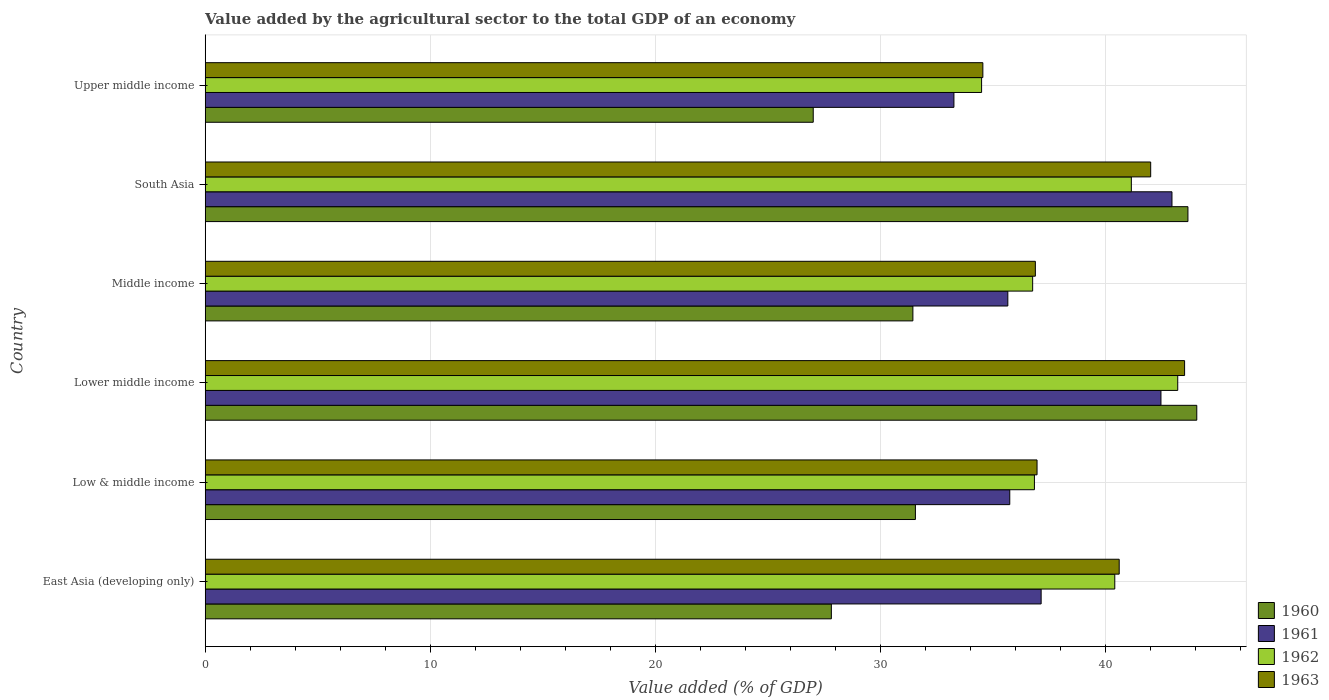How many groups of bars are there?
Your answer should be very brief. 6. Are the number of bars per tick equal to the number of legend labels?
Make the answer very short. Yes. How many bars are there on the 6th tick from the top?
Provide a short and direct response. 4. How many bars are there on the 4th tick from the bottom?
Make the answer very short. 4. In how many cases, is the number of bars for a given country not equal to the number of legend labels?
Give a very brief answer. 0. What is the value added by the agricultural sector to the total GDP in 1962 in South Asia?
Make the answer very short. 41.16. Across all countries, what is the maximum value added by the agricultural sector to the total GDP in 1962?
Your answer should be very brief. 43.22. Across all countries, what is the minimum value added by the agricultural sector to the total GDP in 1962?
Provide a succinct answer. 34.5. In which country was the value added by the agricultural sector to the total GDP in 1960 maximum?
Offer a terse response. Lower middle income. In which country was the value added by the agricultural sector to the total GDP in 1962 minimum?
Your answer should be compact. Upper middle income. What is the total value added by the agricultural sector to the total GDP in 1962 in the graph?
Your answer should be very brief. 232.94. What is the difference between the value added by the agricultural sector to the total GDP in 1960 in East Asia (developing only) and that in Upper middle income?
Provide a succinct answer. 0.81. What is the difference between the value added by the agricultural sector to the total GDP in 1960 in South Asia and the value added by the agricultural sector to the total GDP in 1963 in Middle income?
Your answer should be compact. 6.78. What is the average value added by the agricultural sector to the total GDP in 1963 per country?
Offer a terse response. 39.1. What is the difference between the value added by the agricultural sector to the total GDP in 1961 and value added by the agricultural sector to the total GDP in 1962 in East Asia (developing only)?
Keep it short and to the point. -3.27. In how many countries, is the value added by the agricultural sector to the total GDP in 1960 greater than 4 %?
Your response must be concise. 6. What is the ratio of the value added by the agricultural sector to the total GDP in 1963 in East Asia (developing only) to that in Middle income?
Make the answer very short. 1.1. Is the value added by the agricultural sector to the total GDP in 1962 in Lower middle income less than that in South Asia?
Keep it short and to the point. No. Is the difference between the value added by the agricultural sector to the total GDP in 1961 in Low & middle income and Lower middle income greater than the difference between the value added by the agricultural sector to the total GDP in 1962 in Low & middle income and Lower middle income?
Your answer should be compact. No. What is the difference between the highest and the second highest value added by the agricultural sector to the total GDP in 1962?
Provide a succinct answer. 2.06. What is the difference between the highest and the lowest value added by the agricultural sector to the total GDP in 1961?
Give a very brief answer. 9.69. In how many countries, is the value added by the agricultural sector to the total GDP in 1963 greater than the average value added by the agricultural sector to the total GDP in 1963 taken over all countries?
Give a very brief answer. 3. Is it the case that in every country, the sum of the value added by the agricultural sector to the total GDP in 1962 and value added by the agricultural sector to the total GDP in 1961 is greater than the sum of value added by the agricultural sector to the total GDP in 1963 and value added by the agricultural sector to the total GDP in 1960?
Offer a very short reply. No. What does the 4th bar from the top in Middle income represents?
Give a very brief answer. 1960. What does the 2nd bar from the bottom in South Asia represents?
Offer a very short reply. 1961. Is it the case that in every country, the sum of the value added by the agricultural sector to the total GDP in 1961 and value added by the agricultural sector to the total GDP in 1963 is greater than the value added by the agricultural sector to the total GDP in 1960?
Your answer should be compact. Yes. Are all the bars in the graph horizontal?
Keep it short and to the point. Yes. How many countries are there in the graph?
Give a very brief answer. 6. Are the values on the major ticks of X-axis written in scientific E-notation?
Provide a short and direct response. No. How many legend labels are there?
Offer a terse response. 4. How are the legend labels stacked?
Offer a terse response. Vertical. What is the title of the graph?
Provide a short and direct response. Value added by the agricultural sector to the total GDP of an economy. Does "1983" appear as one of the legend labels in the graph?
Keep it short and to the point. No. What is the label or title of the X-axis?
Your answer should be compact. Value added (% of GDP). What is the Value added (% of GDP) in 1960 in East Asia (developing only)?
Make the answer very short. 27.83. What is the Value added (% of GDP) of 1961 in East Asia (developing only)?
Your answer should be compact. 37.15. What is the Value added (% of GDP) of 1962 in East Asia (developing only)?
Make the answer very short. 40.42. What is the Value added (% of GDP) of 1963 in East Asia (developing only)?
Your answer should be very brief. 40.62. What is the Value added (% of GDP) of 1960 in Low & middle income?
Give a very brief answer. 31.56. What is the Value added (% of GDP) in 1961 in Low & middle income?
Give a very brief answer. 35.76. What is the Value added (% of GDP) in 1962 in Low & middle income?
Keep it short and to the point. 36.85. What is the Value added (% of GDP) in 1963 in Low & middle income?
Offer a terse response. 36.97. What is the Value added (% of GDP) in 1960 in Lower middle income?
Offer a terse response. 44.07. What is the Value added (% of GDP) in 1961 in Lower middle income?
Provide a short and direct response. 42.48. What is the Value added (% of GDP) of 1962 in Lower middle income?
Keep it short and to the point. 43.22. What is the Value added (% of GDP) of 1963 in Lower middle income?
Your answer should be compact. 43.53. What is the Value added (% of GDP) of 1960 in Middle income?
Offer a very short reply. 31.45. What is the Value added (% of GDP) of 1961 in Middle income?
Give a very brief answer. 35.67. What is the Value added (% of GDP) in 1962 in Middle income?
Make the answer very short. 36.77. What is the Value added (% of GDP) of 1963 in Middle income?
Offer a very short reply. 36.89. What is the Value added (% of GDP) of 1960 in South Asia?
Offer a very short reply. 43.68. What is the Value added (% of GDP) of 1961 in South Asia?
Offer a very short reply. 42.96. What is the Value added (% of GDP) in 1962 in South Asia?
Your answer should be very brief. 41.16. What is the Value added (% of GDP) of 1963 in South Asia?
Your response must be concise. 42.02. What is the Value added (% of GDP) of 1960 in Upper middle income?
Your answer should be very brief. 27.02. What is the Value added (% of GDP) in 1961 in Upper middle income?
Your response must be concise. 33.27. What is the Value added (% of GDP) of 1962 in Upper middle income?
Your answer should be compact. 34.5. What is the Value added (% of GDP) of 1963 in Upper middle income?
Your answer should be very brief. 34.56. Across all countries, what is the maximum Value added (% of GDP) of 1960?
Provide a succinct answer. 44.07. Across all countries, what is the maximum Value added (% of GDP) of 1961?
Your answer should be compact. 42.96. Across all countries, what is the maximum Value added (% of GDP) in 1962?
Offer a very short reply. 43.22. Across all countries, what is the maximum Value added (% of GDP) in 1963?
Offer a terse response. 43.53. Across all countries, what is the minimum Value added (% of GDP) in 1960?
Your answer should be compact. 27.02. Across all countries, what is the minimum Value added (% of GDP) of 1961?
Ensure brevity in your answer.  33.27. Across all countries, what is the minimum Value added (% of GDP) of 1962?
Keep it short and to the point. 34.5. Across all countries, what is the minimum Value added (% of GDP) of 1963?
Provide a short and direct response. 34.56. What is the total Value added (% of GDP) of 1960 in the graph?
Make the answer very short. 205.61. What is the total Value added (% of GDP) in 1961 in the graph?
Your answer should be very brief. 227.29. What is the total Value added (% of GDP) in 1962 in the graph?
Provide a succinct answer. 232.94. What is the total Value added (% of GDP) in 1963 in the graph?
Keep it short and to the point. 234.59. What is the difference between the Value added (% of GDP) in 1960 in East Asia (developing only) and that in Low & middle income?
Give a very brief answer. -3.74. What is the difference between the Value added (% of GDP) of 1961 in East Asia (developing only) and that in Low & middle income?
Provide a succinct answer. 1.39. What is the difference between the Value added (% of GDP) in 1962 in East Asia (developing only) and that in Low & middle income?
Make the answer very short. 3.57. What is the difference between the Value added (% of GDP) in 1963 in East Asia (developing only) and that in Low & middle income?
Ensure brevity in your answer.  3.65. What is the difference between the Value added (% of GDP) in 1960 in East Asia (developing only) and that in Lower middle income?
Provide a succinct answer. -16.24. What is the difference between the Value added (% of GDP) in 1961 in East Asia (developing only) and that in Lower middle income?
Provide a succinct answer. -5.33. What is the difference between the Value added (% of GDP) of 1962 in East Asia (developing only) and that in Lower middle income?
Give a very brief answer. -2.8. What is the difference between the Value added (% of GDP) in 1963 in East Asia (developing only) and that in Lower middle income?
Offer a very short reply. -2.91. What is the difference between the Value added (% of GDP) of 1960 in East Asia (developing only) and that in Middle income?
Make the answer very short. -3.62. What is the difference between the Value added (% of GDP) in 1961 in East Asia (developing only) and that in Middle income?
Your response must be concise. 1.48. What is the difference between the Value added (% of GDP) of 1962 in East Asia (developing only) and that in Middle income?
Make the answer very short. 3.65. What is the difference between the Value added (% of GDP) of 1963 in East Asia (developing only) and that in Middle income?
Provide a short and direct response. 3.73. What is the difference between the Value added (% of GDP) of 1960 in East Asia (developing only) and that in South Asia?
Your answer should be very brief. -15.85. What is the difference between the Value added (% of GDP) of 1961 in East Asia (developing only) and that in South Asia?
Give a very brief answer. -5.81. What is the difference between the Value added (% of GDP) in 1962 in East Asia (developing only) and that in South Asia?
Provide a succinct answer. -0.74. What is the difference between the Value added (% of GDP) of 1963 in East Asia (developing only) and that in South Asia?
Provide a short and direct response. -1.4. What is the difference between the Value added (% of GDP) in 1960 in East Asia (developing only) and that in Upper middle income?
Offer a very short reply. 0.81. What is the difference between the Value added (% of GDP) of 1961 in East Asia (developing only) and that in Upper middle income?
Your answer should be compact. 3.88. What is the difference between the Value added (% of GDP) in 1962 in East Asia (developing only) and that in Upper middle income?
Offer a very short reply. 5.92. What is the difference between the Value added (% of GDP) in 1963 in East Asia (developing only) and that in Upper middle income?
Your answer should be compact. 6.06. What is the difference between the Value added (% of GDP) of 1960 in Low & middle income and that in Lower middle income?
Make the answer very short. -12.51. What is the difference between the Value added (% of GDP) of 1961 in Low & middle income and that in Lower middle income?
Make the answer very short. -6.72. What is the difference between the Value added (% of GDP) in 1962 in Low & middle income and that in Lower middle income?
Keep it short and to the point. -6.37. What is the difference between the Value added (% of GDP) of 1963 in Low & middle income and that in Lower middle income?
Offer a very short reply. -6.56. What is the difference between the Value added (% of GDP) in 1960 in Low & middle income and that in Middle income?
Your answer should be compact. 0.11. What is the difference between the Value added (% of GDP) in 1961 in Low & middle income and that in Middle income?
Ensure brevity in your answer.  0.09. What is the difference between the Value added (% of GDP) in 1962 in Low & middle income and that in Middle income?
Your answer should be very brief. 0.08. What is the difference between the Value added (% of GDP) in 1963 in Low & middle income and that in Middle income?
Ensure brevity in your answer.  0.07. What is the difference between the Value added (% of GDP) in 1960 in Low & middle income and that in South Asia?
Provide a succinct answer. -12.11. What is the difference between the Value added (% of GDP) of 1961 in Low & middle income and that in South Asia?
Offer a very short reply. -7.21. What is the difference between the Value added (% of GDP) of 1962 in Low & middle income and that in South Asia?
Keep it short and to the point. -4.31. What is the difference between the Value added (% of GDP) in 1963 in Low & middle income and that in South Asia?
Your answer should be compact. -5.05. What is the difference between the Value added (% of GDP) of 1960 in Low & middle income and that in Upper middle income?
Provide a short and direct response. 4.54. What is the difference between the Value added (% of GDP) of 1961 in Low & middle income and that in Upper middle income?
Your response must be concise. 2.48. What is the difference between the Value added (% of GDP) of 1962 in Low & middle income and that in Upper middle income?
Your answer should be compact. 2.35. What is the difference between the Value added (% of GDP) in 1963 in Low & middle income and that in Upper middle income?
Make the answer very short. 2.41. What is the difference between the Value added (% of GDP) in 1960 in Lower middle income and that in Middle income?
Keep it short and to the point. 12.62. What is the difference between the Value added (% of GDP) in 1961 in Lower middle income and that in Middle income?
Offer a terse response. 6.81. What is the difference between the Value added (% of GDP) in 1962 in Lower middle income and that in Middle income?
Make the answer very short. 6.45. What is the difference between the Value added (% of GDP) in 1963 in Lower middle income and that in Middle income?
Offer a very short reply. 6.63. What is the difference between the Value added (% of GDP) of 1960 in Lower middle income and that in South Asia?
Keep it short and to the point. 0.39. What is the difference between the Value added (% of GDP) of 1961 in Lower middle income and that in South Asia?
Provide a short and direct response. -0.49. What is the difference between the Value added (% of GDP) of 1962 in Lower middle income and that in South Asia?
Keep it short and to the point. 2.06. What is the difference between the Value added (% of GDP) of 1963 in Lower middle income and that in South Asia?
Ensure brevity in your answer.  1.51. What is the difference between the Value added (% of GDP) in 1960 in Lower middle income and that in Upper middle income?
Make the answer very short. 17.05. What is the difference between the Value added (% of GDP) of 1961 in Lower middle income and that in Upper middle income?
Make the answer very short. 9.2. What is the difference between the Value added (% of GDP) in 1962 in Lower middle income and that in Upper middle income?
Ensure brevity in your answer.  8.72. What is the difference between the Value added (% of GDP) of 1963 in Lower middle income and that in Upper middle income?
Your answer should be compact. 8.97. What is the difference between the Value added (% of GDP) of 1960 in Middle income and that in South Asia?
Offer a terse response. -12.22. What is the difference between the Value added (% of GDP) of 1961 in Middle income and that in South Asia?
Offer a terse response. -7.29. What is the difference between the Value added (% of GDP) in 1962 in Middle income and that in South Asia?
Give a very brief answer. -4.39. What is the difference between the Value added (% of GDP) in 1963 in Middle income and that in South Asia?
Ensure brevity in your answer.  -5.13. What is the difference between the Value added (% of GDP) of 1960 in Middle income and that in Upper middle income?
Provide a succinct answer. 4.43. What is the difference between the Value added (% of GDP) of 1961 in Middle income and that in Upper middle income?
Provide a short and direct response. 2.4. What is the difference between the Value added (% of GDP) in 1962 in Middle income and that in Upper middle income?
Your response must be concise. 2.27. What is the difference between the Value added (% of GDP) of 1963 in Middle income and that in Upper middle income?
Offer a very short reply. 2.33. What is the difference between the Value added (% of GDP) of 1960 in South Asia and that in Upper middle income?
Give a very brief answer. 16.65. What is the difference between the Value added (% of GDP) of 1961 in South Asia and that in Upper middle income?
Keep it short and to the point. 9.69. What is the difference between the Value added (% of GDP) of 1962 in South Asia and that in Upper middle income?
Your answer should be compact. 6.66. What is the difference between the Value added (% of GDP) of 1963 in South Asia and that in Upper middle income?
Your answer should be very brief. 7.46. What is the difference between the Value added (% of GDP) of 1960 in East Asia (developing only) and the Value added (% of GDP) of 1961 in Low & middle income?
Provide a short and direct response. -7.93. What is the difference between the Value added (% of GDP) in 1960 in East Asia (developing only) and the Value added (% of GDP) in 1962 in Low & middle income?
Offer a terse response. -9.02. What is the difference between the Value added (% of GDP) in 1960 in East Asia (developing only) and the Value added (% of GDP) in 1963 in Low & middle income?
Your response must be concise. -9.14. What is the difference between the Value added (% of GDP) in 1961 in East Asia (developing only) and the Value added (% of GDP) in 1962 in Low & middle income?
Your response must be concise. 0.3. What is the difference between the Value added (% of GDP) of 1961 in East Asia (developing only) and the Value added (% of GDP) of 1963 in Low & middle income?
Provide a short and direct response. 0.18. What is the difference between the Value added (% of GDP) of 1962 in East Asia (developing only) and the Value added (% of GDP) of 1963 in Low & middle income?
Keep it short and to the point. 3.46. What is the difference between the Value added (% of GDP) in 1960 in East Asia (developing only) and the Value added (% of GDP) in 1961 in Lower middle income?
Provide a short and direct response. -14.65. What is the difference between the Value added (% of GDP) of 1960 in East Asia (developing only) and the Value added (% of GDP) of 1962 in Lower middle income?
Your answer should be very brief. -15.39. What is the difference between the Value added (% of GDP) of 1960 in East Asia (developing only) and the Value added (% of GDP) of 1963 in Lower middle income?
Provide a succinct answer. -15.7. What is the difference between the Value added (% of GDP) of 1961 in East Asia (developing only) and the Value added (% of GDP) of 1962 in Lower middle income?
Offer a terse response. -6.07. What is the difference between the Value added (% of GDP) in 1961 in East Asia (developing only) and the Value added (% of GDP) in 1963 in Lower middle income?
Your answer should be compact. -6.38. What is the difference between the Value added (% of GDP) in 1962 in East Asia (developing only) and the Value added (% of GDP) in 1963 in Lower middle income?
Your answer should be compact. -3.1. What is the difference between the Value added (% of GDP) of 1960 in East Asia (developing only) and the Value added (% of GDP) of 1961 in Middle income?
Provide a succinct answer. -7.84. What is the difference between the Value added (% of GDP) of 1960 in East Asia (developing only) and the Value added (% of GDP) of 1962 in Middle income?
Offer a terse response. -8.95. What is the difference between the Value added (% of GDP) of 1960 in East Asia (developing only) and the Value added (% of GDP) of 1963 in Middle income?
Provide a succinct answer. -9.07. What is the difference between the Value added (% of GDP) of 1961 in East Asia (developing only) and the Value added (% of GDP) of 1962 in Middle income?
Ensure brevity in your answer.  0.38. What is the difference between the Value added (% of GDP) in 1961 in East Asia (developing only) and the Value added (% of GDP) in 1963 in Middle income?
Ensure brevity in your answer.  0.26. What is the difference between the Value added (% of GDP) of 1962 in East Asia (developing only) and the Value added (% of GDP) of 1963 in Middle income?
Make the answer very short. 3.53. What is the difference between the Value added (% of GDP) of 1960 in East Asia (developing only) and the Value added (% of GDP) of 1961 in South Asia?
Offer a very short reply. -15.14. What is the difference between the Value added (% of GDP) in 1960 in East Asia (developing only) and the Value added (% of GDP) in 1962 in South Asia?
Keep it short and to the point. -13.33. What is the difference between the Value added (% of GDP) in 1960 in East Asia (developing only) and the Value added (% of GDP) in 1963 in South Asia?
Your response must be concise. -14.19. What is the difference between the Value added (% of GDP) of 1961 in East Asia (developing only) and the Value added (% of GDP) of 1962 in South Asia?
Offer a very short reply. -4.01. What is the difference between the Value added (% of GDP) of 1961 in East Asia (developing only) and the Value added (% of GDP) of 1963 in South Asia?
Offer a very short reply. -4.87. What is the difference between the Value added (% of GDP) in 1962 in East Asia (developing only) and the Value added (% of GDP) in 1963 in South Asia?
Offer a terse response. -1.6. What is the difference between the Value added (% of GDP) in 1960 in East Asia (developing only) and the Value added (% of GDP) in 1961 in Upper middle income?
Ensure brevity in your answer.  -5.45. What is the difference between the Value added (% of GDP) in 1960 in East Asia (developing only) and the Value added (% of GDP) in 1962 in Upper middle income?
Give a very brief answer. -6.68. What is the difference between the Value added (% of GDP) in 1960 in East Asia (developing only) and the Value added (% of GDP) in 1963 in Upper middle income?
Your response must be concise. -6.73. What is the difference between the Value added (% of GDP) in 1961 in East Asia (developing only) and the Value added (% of GDP) in 1962 in Upper middle income?
Give a very brief answer. 2.65. What is the difference between the Value added (% of GDP) of 1961 in East Asia (developing only) and the Value added (% of GDP) of 1963 in Upper middle income?
Keep it short and to the point. 2.59. What is the difference between the Value added (% of GDP) of 1962 in East Asia (developing only) and the Value added (% of GDP) of 1963 in Upper middle income?
Your answer should be very brief. 5.86. What is the difference between the Value added (% of GDP) of 1960 in Low & middle income and the Value added (% of GDP) of 1961 in Lower middle income?
Your response must be concise. -10.91. What is the difference between the Value added (% of GDP) in 1960 in Low & middle income and the Value added (% of GDP) in 1962 in Lower middle income?
Your answer should be compact. -11.66. What is the difference between the Value added (% of GDP) of 1960 in Low & middle income and the Value added (% of GDP) of 1963 in Lower middle income?
Your response must be concise. -11.96. What is the difference between the Value added (% of GDP) in 1961 in Low & middle income and the Value added (% of GDP) in 1962 in Lower middle income?
Keep it short and to the point. -7.47. What is the difference between the Value added (% of GDP) of 1961 in Low & middle income and the Value added (% of GDP) of 1963 in Lower middle income?
Give a very brief answer. -7.77. What is the difference between the Value added (% of GDP) of 1962 in Low & middle income and the Value added (% of GDP) of 1963 in Lower middle income?
Make the answer very short. -6.67. What is the difference between the Value added (% of GDP) of 1960 in Low & middle income and the Value added (% of GDP) of 1961 in Middle income?
Ensure brevity in your answer.  -4.11. What is the difference between the Value added (% of GDP) in 1960 in Low & middle income and the Value added (% of GDP) in 1962 in Middle income?
Provide a short and direct response. -5.21. What is the difference between the Value added (% of GDP) in 1960 in Low & middle income and the Value added (% of GDP) in 1963 in Middle income?
Your answer should be compact. -5.33. What is the difference between the Value added (% of GDP) of 1961 in Low & middle income and the Value added (% of GDP) of 1962 in Middle income?
Ensure brevity in your answer.  -1.02. What is the difference between the Value added (% of GDP) of 1961 in Low & middle income and the Value added (% of GDP) of 1963 in Middle income?
Make the answer very short. -1.14. What is the difference between the Value added (% of GDP) of 1962 in Low & middle income and the Value added (% of GDP) of 1963 in Middle income?
Provide a short and direct response. -0.04. What is the difference between the Value added (% of GDP) in 1960 in Low & middle income and the Value added (% of GDP) in 1961 in South Asia?
Your answer should be very brief. -11.4. What is the difference between the Value added (% of GDP) in 1960 in Low & middle income and the Value added (% of GDP) in 1962 in South Asia?
Provide a short and direct response. -9.6. What is the difference between the Value added (% of GDP) in 1960 in Low & middle income and the Value added (% of GDP) in 1963 in South Asia?
Provide a short and direct response. -10.46. What is the difference between the Value added (% of GDP) in 1961 in Low & middle income and the Value added (% of GDP) in 1962 in South Asia?
Make the answer very short. -5.4. What is the difference between the Value added (% of GDP) of 1961 in Low & middle income and the Value added (% of GDP) of 1963 in South Asia?
Offer a terse response. -6.26. What is the difference between the Value added (% of GDP) in 1962 in Low & middle income and the Value added (% of GDP) in 1963 in South Asia?
Ensure brevity in your answer.  -5.17. What is the difference between the Value added (% of GDP) of 1960 in Low & middle income and the Value added (% of GDP) of 1961 in Upper middle income?
Ensure brevity in your answer.  -1.71. What is the difference between the Value added (% of GDP) of 1960 in Low & middle income and the Value added (% of GDP) of 1962 in Upper middle income?
Keep it short and to the point. -2.94. What is the difference between the Value added (% of GDP) in 1960 in Low & middle income and the Value added (% of GDP) in 1963 in Upper middle income?
Make the answer very short. -3. What is the difference between the Value added (% of GDP) of 1961 in Low & middle income and the Value added (% of GDP) of 1962 in Upper middle income?
Ensure brevity in your answer.  1.25. What is the difference between the Value added (% of GDP) of 1961 in Low & middle income and the Value added (% of GDP) of 1963 in Upper middle income?
Offer a very short reply. 1.2. What is the difference between the Value added (% of GDP) of 1962 in Low & middle income and the Value added (% of GDP) of 1963 in Upper middle income?
Keep it short and to the point. 2.29. What is the difference between the Value added (% of GDP) of 1960 in Lower middle income and the Value added (% of GDP) of 1961 in Middle income?
Provide a succinct answer. 8.4. What is the difference between the Value added (% of GDP) in 1960 in Lower middle income and the Value added (% of GDP) in 1962 in Middle income?
Make the answer very short. 7.29. What is the difference between the Value added (% of GDP) of 1960 in Lower middle income and the Value added (% of GDP) of 1963 in Middle income?
Offer a terse response. 7.17. What is the difference between the Value added (% of GDP) in 1961 in Lower middle income and the Value added (% of GDP) in 1962 in Middle income?
Offer a very short reply. 5.7. What is the difference between the Value added (% of GDP) of 1961 in Lower middle income and the Value added (% of GDP) of 1963 in Middle income?
Provide a succinct answer. 5.58. What is the difference between the Value added (% of GDP) in 1962 in Lower middle income and the Value added (% of GDP) in 1963 in Middle income?
Keep it short and to the point. 6.33. What is the difference between the Value added (% of GDP) of 1960 in Lower middle income and the Value added (% of GDP) of 1961 in South Asia?
Your answer should be compact. 1.1. What is the difference between the Value added (% of GDP) in 1960 in Lower middle income and the Value added (% of GDP) in 1962 in South Asia?
Provide a short and direct response. 2.91. What is the difference between the Value added (% of GDP) of 1960 in Lower middle income and the Value added (% of GDP) of 1963 in South Asia?
Offer a very short reply. 2.05. What is the difference between the Value added (% of GDP) in 1961 in Lower middle income and the Value added (% of GDP) in 1962 in South Asia?
Your answer should be very brief. 1.32. What is the difference between the Value added (% of GDP) of 1961 in Lower middle income and the Value added (% of GDP) of 1963 in South Asia?
Your response must be concise. 0.46. What is the difference between the Value added (% of GDP) in 1962 in Lower middle income and the Value added (% of GDP) in 1963 in South Asia?
Your response must be concise. 1.2. What is the difference between the Value added (% of GDP) of 1960 in Lower middle income and the Value added (% of GDP) of 1961 in Upper middle income?
Make the answer very short. 10.79. What is the difference between the Value added (% of GDP) in 1960 in Lower middle income and the Value added (% of GDP) in 1962 in Upper middle income?
Offer a very short reply. 9.56. What is the difference between the Value added (% of GDP) of 1960 in Lower middle income and the Value added (% of GDP) of 1963 in Upper middle income?
Your answer should be compact. 9.51. What is the difference between the Value added (% of GDP) of 1961 in Lower middle income and the Value added (% of GDP) of 1962 in Upper middle income?
Give a very brief answer. 7.97. What is the difference between the Value added (% of GDP) of 1961 in Lower middle income and the Value added (% of GDP) of 1963 in Upper middle income?
Your answer should be very brief. 7.92. What is the difference between the Value added (% of GDP) in 1962 in Lower middle income and the Value added (% of GDP) in 1963 in Upper middle income?
Your answer should be compact. 8.66. What is the difference between the Value added (% of GDP) of 1960 in Middle income and the Value added (% of GDP) of 1961 in South Asia?
Keep it short and to the point. -11.51. What is the difference between the Value added (% of GDP) in 1960 in Middle income and the Value added (% of GDP) in 1962 in South Asia?
Offer a terse response. -9.71. What is the difference between the Value added (% of GDP) in 1960 in Middle income and the Value added (% of GDP) in 1963 in South Asia?
Keep it short and to the point. -10.57. What is the difference between the Value added (% of GDP) of 1961 in Middle income and the Value added (% of GDP) of 1962 in South Asia?
Your answer should be very brief. -5.49. What is the difference between the Value added (% of GDP) of 1961 in Middle income and the Value added (% of GDP) of 1963 in South Asia?
Your response must be concise. -6.35. What is the difference between the Value added (% of GDP) in 1962 in Middle income and the Value added (% of GDP) in 1963 in South Asia?
Your answer should be very brief. -5.25. What is the difference between the Value added (% of GDP) in 1960 in Middle income and the Value added (% of GDP) in 1961 in Upper middle income?
Your answer should be very brief. -1.82. What is the difference between the Value added (% of GDP) of 1960 in Middle income and the Value added (% of GDP) of 1962 in Upper middle income?
Ensure brevity in your answer.  -3.05. What is the difference between the Value added (% of GDP) in 1960 in Middle income and the Value added (% of GDP) in 1963 in Upper middle income?
Ensure brevity in your answer.  -3.11. What is the difference between the Value added (% of GDP) of 1961 in Middle income and the Value added (% of GDP) of 1962 in Upper middle income?
Keep it short and to the point. 1.17. What is the difference between the Value added (% of GDP) in 1961 in Middle income and the Value added (% of GDP) in 1963 in Upper middle income?
Your answer should be compact. 1.11. What is the difference between the Value added (% of GDP) in 1962 in Middle income and the Value added (% of GDP) in 1963 in Upper middle income?
Offer a terse response. 2.21. What is the difference between the Value added (% of GDP) of 1960 in South Asia and the Value added (% of GDP) of 1961 in Upper middle income?
Make the answer very short. 10.4. What is the difference between the Value added (% of GDP) of 1960 in South Asia and the Value added (% of GDP) of 1962 in Upper middle income?
Offer a terse response. 9.17. What is the difference between the Value added (% of GDP) of 1960 in South Asia and the Value added (% of GDP) of 1963 in Upper middle income?
Give a very brief answer. 9.11. What is the difference between the Value added (% of GDP) in 1961 in South Asia and the Value added (% of GDP) in 1962 in Upper middle income?
Provide a succinct answer. 8.46. What is the difference between the Value added (% of GDP) of 1961 in South Asia and the Value added (% of GDP) of 1963 in Upper middle income?
Ensure brevity in your answer.  8.4. What is the difference between the Value added (% of GDP) of 1962 in South Asia and the Value added (% of GDP) of 1963 in Upper middle income?
Your answer should be compact. 6.6. What is the average Value added (% of GDP) of 1960 per country?
Keep it short and to the point. 34.27. What is the average Value added (% of GDP) in 1961 per country?
Offer a very short reply. 37.88. What is the average Value added (% of GDP) of 1962 per country?
Offer a terse response. 38.82. What is the average Value added (% of GDP) in 1963 per country?
Provide a short and direct response. 39.1. What is the difference between the Value added (% of GDP) in 1960 and Value added (% of GDP) in 1961 in East Asia (developing only)?
Give a very brief answer. -9.32. What is the difference between the Value added (% of GDP) in 1960 and Value added (% of GDP) in 1962 in East Asia (developing only)?
Give a very brief answer. -12.6. What is the difference between the Value added (% of GDP) in 1960 and Value added (% of GDP) in 1963 in East Asia (developing only)?
Make the answer very short. -12.79. What is the difference between the Value added (% of GDP) in 1961 and Value added (% of GDP) in 1962 in East Asia (developing only)?
Offer a very short reply. -3.27. What is the difference between the Value added (% of GDP) of 1961 and Value added (% of GDP) of 1963 in East Asia (developing only)?
Your answer should be very brief. -3.47. What is the difference between the Value added (% of GDP) of 1962 and Value added (% of GDP) of 1963 in East Asia (developing only)?
Keep it short and to the point. -0.2. What is the difference between the Value added (% of GDP) in 1960 and Value added (% of GDP) in 1961 in Low & middle income?
Ensure brevity in your answer.  -4.19. What is the difference between the Value added (% of GDP) in 1960 and Value added (% of GDP) in 1962 in Low & middle income?
Your answer should be compact. -5.29. What is the difference between the Value added (% of GDP) in 1960 and Value added (% of GDP) in 1963 in Low & middle income?
Your answer should be very brief. -5.41. What is the difference between the Value added (% of GDP) in 1961 and Value added (% of GDP) in 1962 in Low & middle income?
Offer a terse response. -1.1. What is the difference between the Value added (% of GDP) in 1961 and Value added (% of GDP) in 1963 in Low & middle income?
Provide a succinct answer. -1.21. What is the difference between the Value added (% of GDP) of 1962 and Value added (% of GDP) of 1963 in Low & middle income?
Keep it short and to the point. -0.12. What is the difference between the Value added (% of GDP) in 1960 and Value added (% of GDP) in 1961 in Lower middle income?
Your answer should be compact. 1.59. What is the difference between the Value added (% of GDP) in 1960 and Value added (% of GDP) in 1962 in Lower middle income?
Give a very brief answer. 0.85. What is the difference between the Value added (% of GDP) in 1960 and Value added (% of GDP) in 1963 in Lower middle income?
Provide a short and direct response. 0.54. What is the difference between the Value added (% of GDP) of 1961 and Value added (% of GDP) of 1962 in Lower middle income?
Offer a terse response. -0.75. What is the difference between the Value added (% of GDP) of 1961 and Value added (% of GDP) of 1963 in Lower middle income?
Keep it short and to the point. -1.05. What is the difference between the Value added (% of GDP) in 1962 and Value added (% of GDP) in 1963 in Lower middle income?
Offer a very short reply. -0.3. What is the difference between the Value added (% of GDP) in 1960 and Value added (% of GDP) in 1961 in Middle income?
Your response must be concise. -4.22. What is the difference between the Value added (% of GDP) in 1960 and Value added (% of GDP) in 1962 in Middle income?
Provide a succinct answer. -5.32. What is the difference between the Value added (% of GDP) of 1960 and Value added (% of GDP) of 1963 in Middle income?
Your answer should be very brief. -5.44. What is the difference between the Value added (% of GDP) of 1961 and Value added (% of GDP) of 1962 in Middle income?
Your answer should be very brief. -1.1. What is the difference between the Value added (% of GDP) in 1961 and Value added (% of GDP) in 1963 in Middle income?
Keep it short and to the point. -1.22. What is the difference between the Value added (% of GDP) of 1962 and Value added (% of GDP) of 1963 in Middle income?
Keep it short and to the point. -0.12. What is the difference between the Value added (% of GDP) of 1960 and Value added (% of GDP) of 1961 in South Asia?
Provide a short and direct response. 0.71. What is the difference between the Value added (% of GDP) in 1960 and Value added (% of GDP) in 1962 in South Asia?
Make the answer very short. 2.52. What is the difference between the Value added (% of GDP) in 1960 and Value added (% of GDP) in 1963 in South Asia?
Give a very brief answer. 1.66. What is the difference between the Value added (% of GDP) in 1961 and Value added (% of GDP) in 1962 in South Asia?
Provide a short and direct response. 1.8. What is the difference between the Value added (% of GDP) in 1961 and Value added (% of GDP) in 1963 in South Asia?
Provide a succinct answer. 0.95. What is the difference between the Value added (% of GDP) of 1962 and Value added (% of GDP) of 1963 in South Asia?
Your response must be concise. -0.86. What is the difference between the Value added (% of GDP) of 1960 and Value added (% of GDP) of 1961 in Upper middle income?
Provide a succinct answer. -6.25. What is the difference between the Value added (% of GDP) in 1960 and Value added (% of GDP) in 1962 in Upper middle income?
Your answer should be very brief. -7.48. What is the difference between the Value added (% of GDP) in 1960 and Value added (% of GDP) in 1963 in Upper middle income?
Offer a very short reply. -7.54. What is the difference between the Value added (% of GDP) in 1961 and Value added (% of GDP) in 1962 in Upper middle income?
Provide a succinct answer. -1.23. What is the difference between the Value added (% of GDP) in 1961 and Value added (% of GDP) in 1963 in Upper middle income?
Provide a succinct answer. -1.29. What is the difference between the Value added (% of GDP) of 1962 and Value added (% of GDP) of 1963 in Upper middle income?
Your answer should be compact. -0.06. What is the ratio of the Value added (% of GDP) in 1960 in East Asia (developing only) to that in Low & middle income?
Keep it short and to the point. 0.88. What is the ratio of the Value added (% of GDP) in 1961 in East Asia (developing only) to that in Low & middle income?
Your answer should be compact. 1.04. What is the ratio of the Value added (% of GDP) of 1962 in East Asia (developing only) to that in Low & middle income?
Give a very brief answer. 1.1. What is the ratio of the Value added (% of GDP) in 1963 in East Asia (developing only) to that in Low & middle income?
Keep it short and to the point. 1.1. What is the ratio of the Value added (% of GDP) of 1960 in East Asia (developing only) to that in Lower middle income?
Offer a very short reply. 0.63. What is the ratio of the Value added (% of GDP) in 1961 in East Asia (developing only) to that in Lower middle income?
Provide a succinct answer. 0.87. What is the ratio of the Value added (% of GDP) in 1962 in East Asia (developing only) to that in Lower middle income?
Offer a terse response. 0.94. What is the ratio of the Value added (% of GDP) in 1963 in East Asia (developing only) to that in Lower middle income?
Your answer should be very brief. 0.93. What is the ratio of the Value added (% of GDP) in 1960 in East Asia (developing only) to that in Middle income?
Give a very brief answer. 0.88. What is the ratio of the Value added (% of GDP) in 1961 in East Asia (developing only) to that in Middle income?
Provide a short and direct response. 1.04. What is the ratio of the Value added (% of GDP) of 1962 in East Asia (developing only) to that in Middle income?
Your answer should be compact. 1.1. What is the ratio of the Value added (% of GDP) of 1963 in East Asia (developing only) to that in Middle income?
Keep it short and to the point. 1.1. What is the ratio of the Value added (% of GDP) of 1960 in East Asia (developing only) to that in South Asia?
Provide a short and direct response. 0.64. What is the ratio of the Value added (% of GDP) in 1961 in East Asia (developing only) to that in South Asia?
Your answer should be compact. 0.86. What is the ratio of the Value added (% of GDP) in 1962 in East Asia (developing only) to that in South Asia?
Make the answer very short. 0.98. What is the ratio of the Value added (% of GDP) in 1963 in East Asia (developing only) to that in South Asia?
Your answer should be very brief. 0.97. What is the ratio of the Value added (% of GDP) in 1960 in East Asia (developing only) to that in Upper middle income?
Your response must be concise. 1.03. What is the ratio of the Value added (% of GDP) of 1961 in East Asia (developing only) to that in Upper middle income?
Provide a succinct answer. 1.12. What is the ratio of the Value added (% of GDP) in 1962 in East Asia (developing only) to that in Upper middle income?
Your answer should be very brief. 1.17. What is the ratio of the Value added (% of GDP) in 1963 in East Asia (developing only) to that in Upper middle income?
Keep it short and to the point. 1.18. What is the ratio of the Value added (% of GDP) in 1960 in Low & middle income to that in Lower middle income?
Offer a terse response. 0.72. What is the ratio of the Value added (% of GDP) in 1961 in Low & middle income to that in Lower middle income?
Offer a terse response. 0.84. What is the ratio of the Value added (% of GDP) of 1962 in Low & middle income to that in Lower middle income?
Keep it short and to the point. 0.85. What is the ratio of the Value added (% of GDP) in 1963 in Low & middle income to that in Lower middle income?
Your answer should be very brief. 0.85. What is the ratio of the Value added (% of GDP) in 1960 in Low & middle income to that in Middle income?
Make the answer very short. 1. What is the ratio of the Value added (% of GDP) in 1961 in Low & middle income to that in Middle income?
Ensure brevity in your answer.  1. What is the ratio of the Value added (% of GDP) of 1960 in Low & middle income to that in South Asia?
Provide a short and direct response. 0.72. What is the ratio of the Value added (% of GDP) of 1961 in Low & middle income to that in South Asia?
Ensure brevity in your answer.  0.83. What is the ratio of the Value added (% of GDP) of 1962 in Low & middle income to that in South Asia?
Make the answer very short. 0.9. What is the ratio of the Value added (% of GDP) in 1963 in Low & middle income to that in South Asia?
Offer a very short reply. 0.88. What is the ratio of the Value added (% of GDP) of 1960 in Low & middle income to that in Upper middle income?
Offer a very short reply. 1.17. What is the ratio of the Value added (% of GDP) in 1961 in Low & middle income to that in Upper middle income?
Your answer should be very brief. 1.07. What is the ratio of the Value added (% of GDP) in 1962 in Low & middle income to that in Upper middle income?
Offer a very short reply. 1.07. What is the ratio of the Value added (% of GDP) of 1963 in Low & middle income to that in Upper middle income?
Provide a succinct answer. 1.07. What is the ratio of the Value added (% of GDP) in 1960 in Lower middle income to that in Middle income?
Your answer should be compact. 1.4. What is the ratio of the Value added (% of GDP) in 1961 in Lower middle income to that in Middle income?
Your answer should be compact. 1.19. What is the ratio of the Value added (% of GDP) in 1962 in Lower middle income to that in Middle income?
Your answer should be compact. 1.18. What is the ratio of the Value added (% of GDP) of 1963 in Lower middle income to that in Middle income?
Provide a short and direct response. 1.18. What is the ratio of the Value added (% of GDP) in 1960 in Lower middle income to that in South Asia?
Give a very brief answer. 1.01. What is the ratio of the Value added (% of GDP) of 1962 in Lower middle income to that in South Asia?
Your answer should be very brief. 1.05. What is the ratio of the Value added (% of GDP) in 1963 in Lower middle income to that in South Asia?
Make the answer very short. 1.04. What is the ratio of the Value added (% of GDP) of 1960 in Lower middle income to that in Upper middle income?
Offer a terse response. 1.63. What is the ratio of the Value added (% of GDP) in 1961 in Lower middle income to that in Upper middle income?
Ensure brevity in your answer.  1.28. What is the ratio of the Value added (% of GDP) of 1962 in Lower middle income to that in Upper middle income?
Offer a very short reply. 1.25. What is the ratio of the Value added (% of GDP) in 1963 in Lower middle income to that in Upper middle income?
Give a very brief answer. 1.26. What is the ratio of the Value added (% of GDP) of 1960 in Middle income to that in South Asia?
Offer a very short reply. 0.72. What is the ratio of the Value added (% of GDP) of 1961 in Middle income to that in South Asia?
Your answer should be compact. 0.83. What is the ratio of the Value added (% of GDP) of 1962 in Middle income to that in South Asia?
Your answer should be compact. 0.89. What is the ratio of the Value added (% of GDP) in 1963 in Middle income to that in South Asia?
Ensure brevity in your answer.  0.88. What is the ratio of the Value added (% of GDP) in 1960 in Middle income to that in Upper middle income?
Your answer should be compact. 1.16. What is the ratio of the Value added (% of GDP) in 1961 in Middle income to that in Upper middle income?
Keep it short and to the point. 1.07. What is the ratio of the Value added (% of GDP) of 1962 in Middle income to that in Upper middle income?
Give a very brief answer. 1.07. What is the ratio of the Value added (% of GDP) of 1963 in Middle income to that in Upper middle income?
Provide a short and direct response. 1.07. What is the ratio of the Value added (% of GDP) of 1960 in South Asia to that in Upper middle income?
Your answer should be compact. 1.62. What is the ratio of the Value added (% of GDP) in 1961 in South Asia to that in Upper middle income?
Give a very brief answer. 1.29. What is the ratio of the Value added (% of GDP) of 1962 in South Asia to that in Upper middle income?
Offer a terse response. 1.19. What is the ratio of the Value added (% of GDP) of 1963 in South Asia to that in Upper middle income?
Provide a succinct answer. 1.22. What is the difference between the highest and the second highest Value added (% of GDP) of 1960?
Your answer should be compact. 0.39. What is the difference between the highest and the second highest Value added (% of GDP) of 1961?
Your answer should be very brief. 0.49. What is the difference between the highest and the second highest Value added (% of GDP) of 1962?
Give a very brief answer. 2.06. What is the difference between the highest and the second highest Value added (% of GDP) in 1963?
Keep it short and to the point. 1.51. What is the difference between the highest and the lowest Value added (% of GDP) of 1960?
Keep it short and to the point. 17.05. What is the difference between the highest and the lowest Value added (% of GDP) in 1961?
Your answer should be very brief. 9.69. What is the difference between the highest and the lowest Value added (% of GDP) of 1962?
Provide a short and direct response. 8.72. What is the difference between the highest and the lowest Value added (% of GDP) of 1963?
Keep it short and to the point. 8.97. 